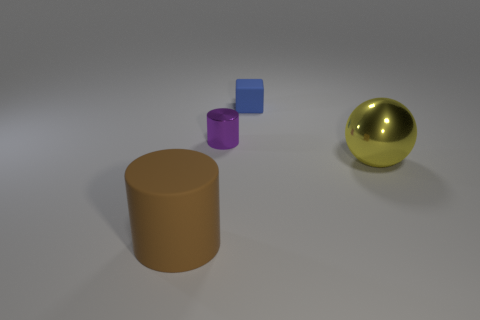Add 2 gray cubes. How many objects exist? 6 Subtract all brown cylinders. How many cylinders are left? 1 Subtract 0 purple spheres. How many objects are left? 4 Subtract all spheres. How many objects are left? 3 Subtract all green spheres. Subtract all gray cylinders. How many spheres are left? 1 Subtract all purple cylinders. Subtract all large balls. How many objects are left? 2 Add 2 blue rubber objects. How many blue rubber objects are left? 3 Add 4 tiny cyan shiny blocks. How many tiny cyan shiny blocks exist? 4 